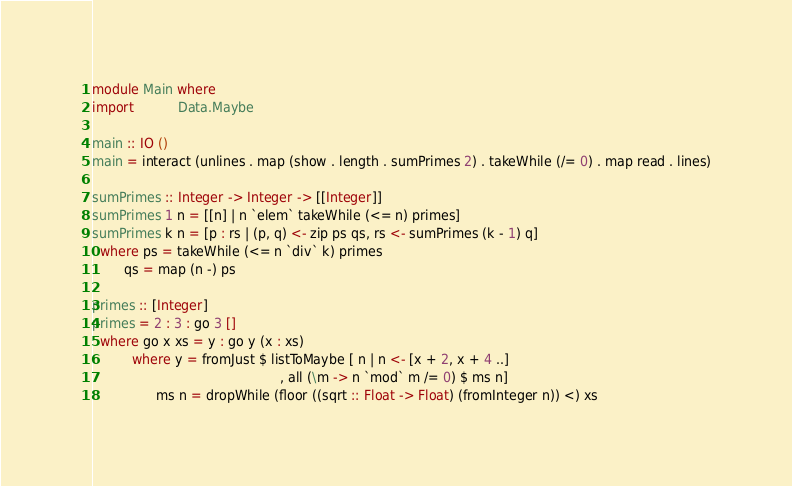Convert code to text. <code><loc_0><loc_0><loc_500><loc_500><_Haskell_>module Main where
import           Data.Maybe

main :: IO ()
main = interact (unlines . map (show . length . sumPrimes 2) . takeWhile (/= 0) . map read . lines)

sumPrimes :: Integer -> Integer -> [[Integer]]
sumPrimes 1 n = [[n] | n `elem` takeWhile (<= n) primes]
sumPrimes k n = [p : rs | (p, q) <- zip ps qs, rs <- sumPrimes (k - 1) q]
  where ps = takeWhile (<= n `div` k) primes
        qs = map (n -) ps

primes :: [Integer]
primes = 2 : 3 : go 3 []
  where go x xs = y : go y (x : xs)
          where y = fromJust $ listToMaybe [ n | n <- [x + 2, x + 4 ..]
                                               , all (\m -> n `mod` m /= 0) $ ms n]
                ms n = dropWhile (floor ((sqrt :: Float -> Float) (fromInteger n)) <) xs</code> 